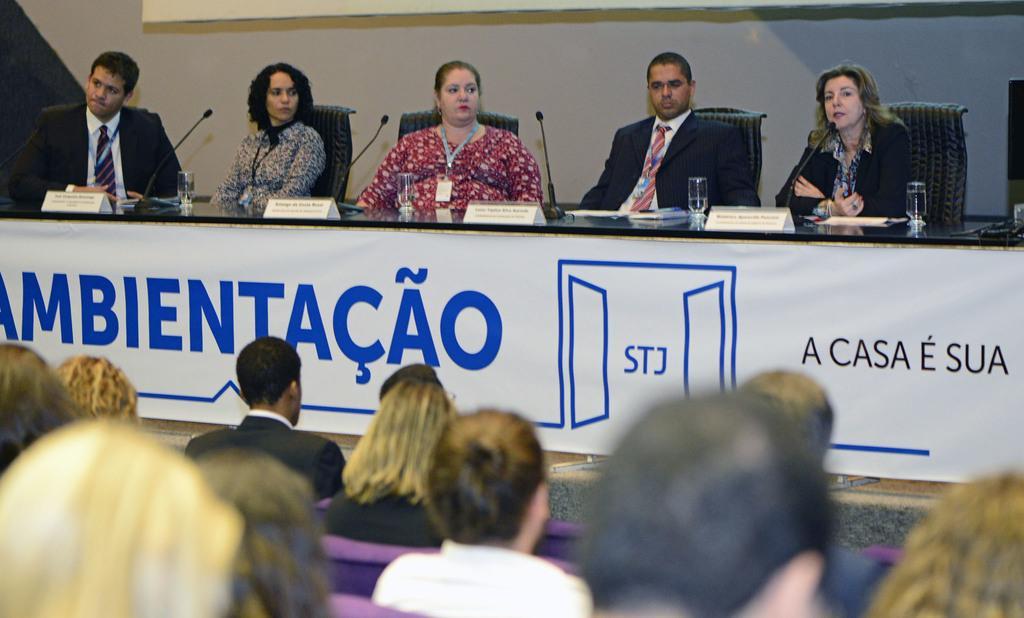Can you describe this image briefly? There are many people sitting on chairs. In front of them there is a platform. On that there are mice, glasses and name boards. Also there is a banner. In front of them there are many people sitting. In the back there is a wall. 